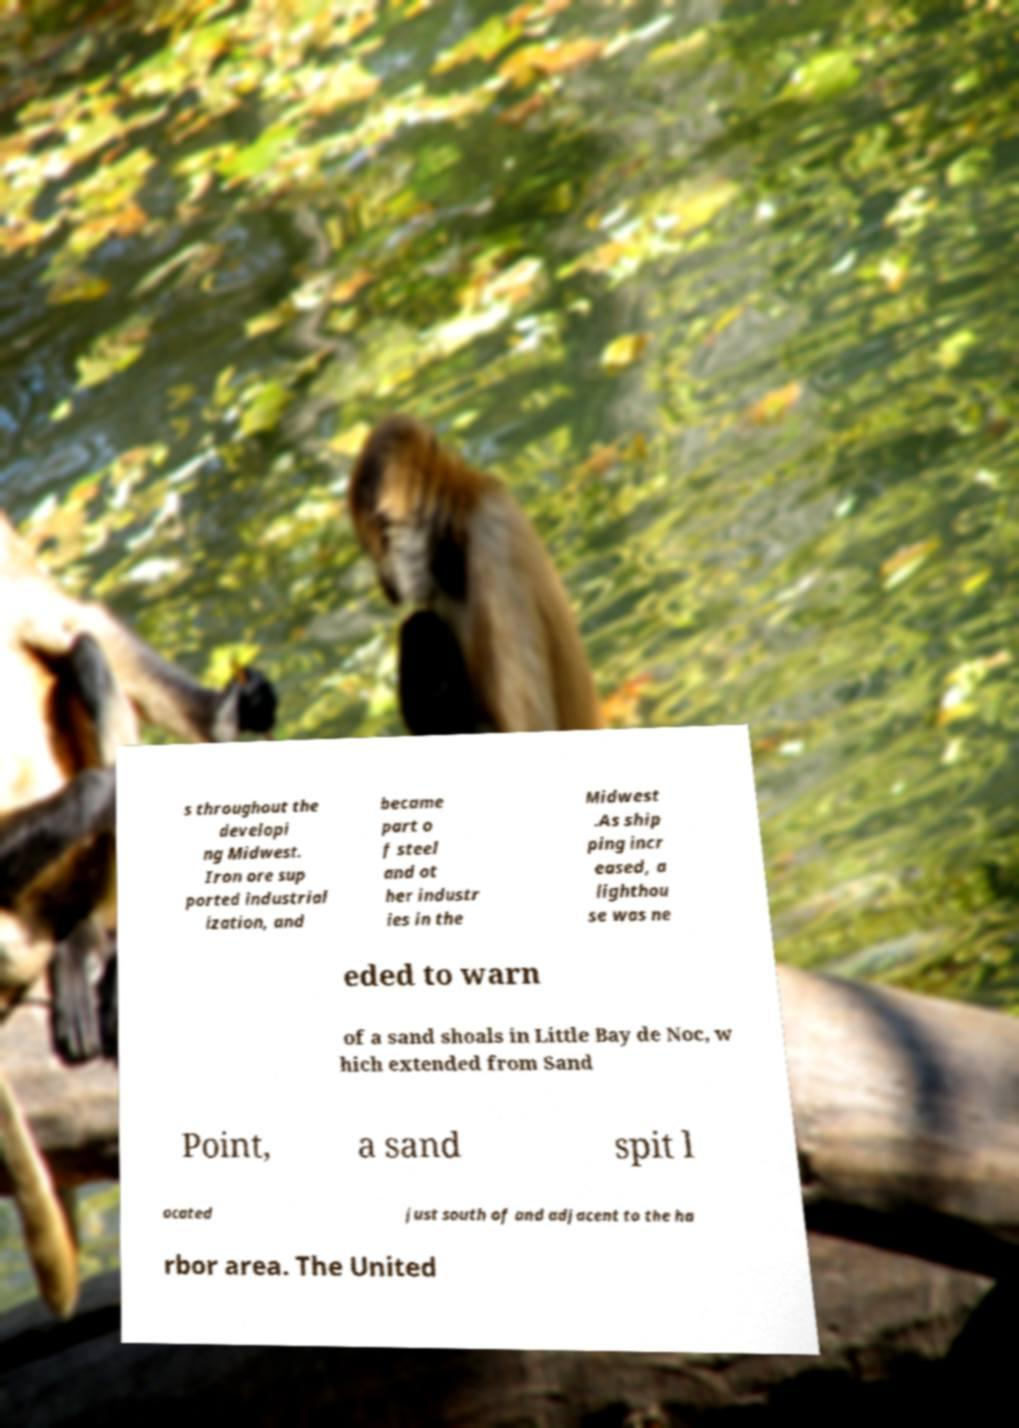Could you extract and type out the text from this image? s throughout the developi ng Midwest. Iron ore sup ported industrial ization, and became part o f steel and ot her industr ies in the Midwest .As ship ping incr eased, a lighthou se was ne eded to warn of a sand shoals in Little Bay de Noc, w hich extended from Sand Point, a sand spit l ocated just south of and adjacent to the ha rbor area. The United 